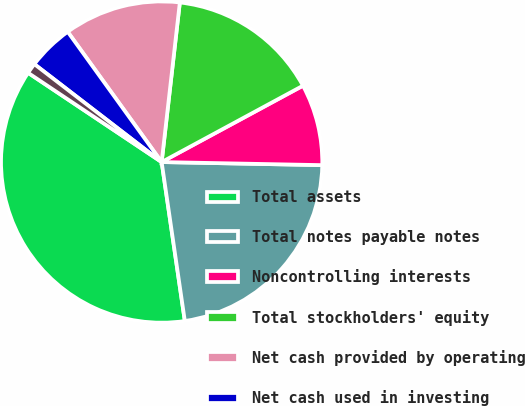Convert chart to OTSL. <chart><loc_0><loc_0><loc_500><loc_500><pie_chart><fcel>Total assets<fcel>Total notes payable notes<fcel>Noncontrolling interests<fcel>Total stockholders' equity<fcel>Net cash provided by operating<fcel>Net cash used in investing<fcel>Net cash provided by financing<nl><fcel>36.68%<fcel>22.39%<fcel>8.19%<fcel>15.31%<fcel>11.75%<fcel>4.62%<fcel>1.06%<nl></chart> 